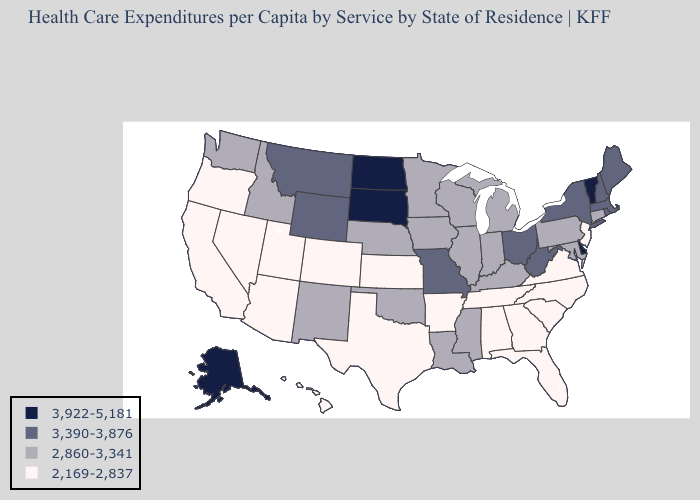What is the highest value in the Northeast ?
Concise answer only. 3,922-5,181. Name the states that have a value in the range 3,922-5,181?
Keep it brief. Alaska, Delaware, North Dakota, South Dakota, Vermont. What is the value of Indiana?
Give a very brief answer. 2,860-3,341. Name the states that have a value in the range 3,922-5,181?
Be succinct. Alaska, Delaware, North Dakota, South Dakota, Vermont. Name the states that have a value in the range 2,169-2,837?
Give a very brief answer. Alabama, Arizona, Arkansas, California, Colorado, Florida, Georgia, Hawaii, Kansas, Nevada, New Jersey, North Carolina, Oregon, South Carolina, Tennessee, Texas, Utah, Virginia. What is the value of New Hampshire?
Answer briefly. 3,390-3,876. What is the highest value in the South ?
Keep it brief. 3,922-5,181. What is the value of Maryland?
Short answer required. 2,860-3,341. Name the states that have a value in the range 3,390-3,876?
Short answer required. Maine, Massachusetts, Missouri, Montana, New Hampshire, New York, Ohio, Rhode Island, West Virginia, Wyoming. Name the states that have a value in the range 3,922-5,181?
Be succinct. Alaska, Delaware, North Dakota, South Dakota, Vermont. How many symbols are there in the legend?
Concise answer only. 4. Name the states that have a value in the range 2,169-2,837?
Answer briefly. Alabama, Arizona, Arkansas, California, Colorado, Florida, Georgia, Hawaii, Kansas, Nevada, New Jersey, North Carolina, Oregon, South Carolina, Tennessee, Texas, Utah, Virginia. Does Wisconsin have a lower value than Missouri?
Concise answer only. Yes. Among the states that border Ohio , which have the lowest value?
Quick response, please. Indiana, Kentucky, Michigan, Pennsylvania. How many symbols are there in the legend?
Give a very brief answer. 4. 